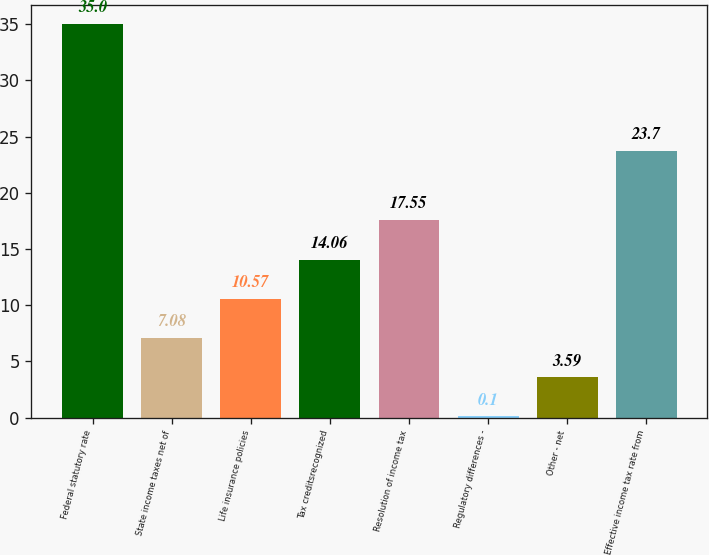<chart> <loc_0><loc_0><loc_500><loc_500><bar_chart><fcel>Federal statutory rate<fcel>State income taxes net of<fcel>Life insurance policies<fcel>Tax creditsrecognized<fcel>Resolution of income tax<fcel>Regulatory differences -<fcel>Other - net<fcel>Effective income tax rate from<nl><fcel>35<fcel>7.08<fcel>10.57<fcel>14.06<fcel>17.55<fcel>0.1<fcel>3.59<fcel>23.7<nl></chart> 